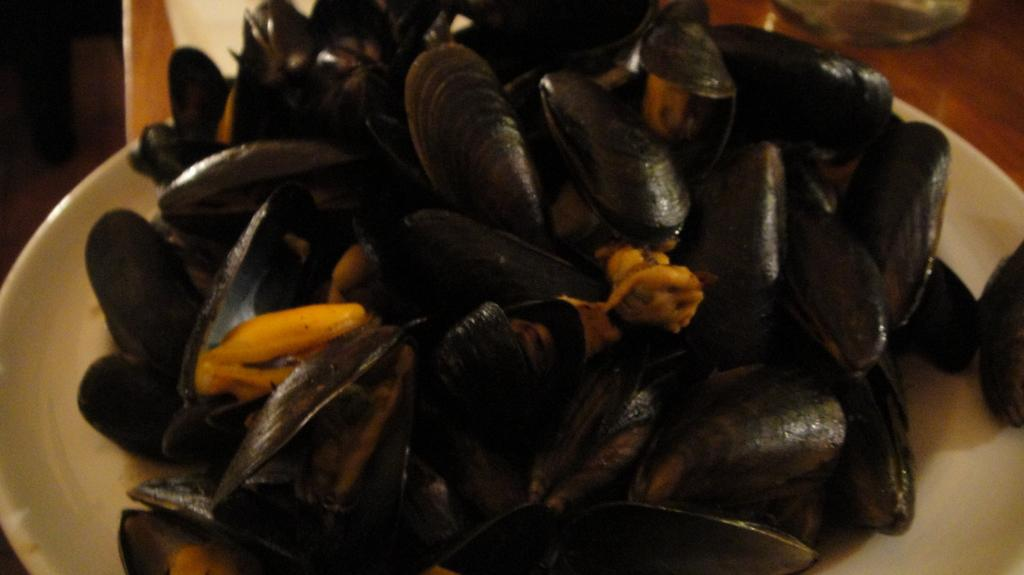What is the color of the plate in the image? The plate in the image is white. What is on top of the plate? There are black color shells on the plate. What type of oil is being used to cook the shells in the image? There is no indication of cooking or oil in the image; it only shows a white plate with black color shells on it. 